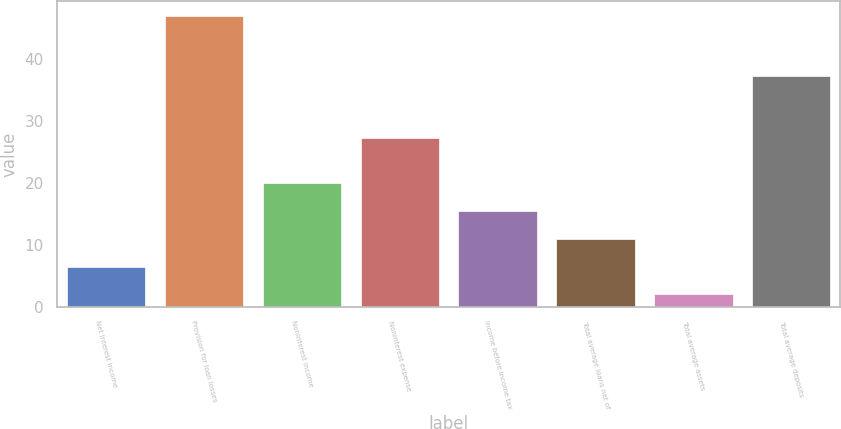Convert chart to OTSL. <chart><loc_0><loc_0><loc_500><loc_500><bar_chart><fcel>Net interest income<fcel>Provision for loan losses<fcel>Noninterest income<fcel>Noninterest expense<fcel>Income before income tax<fcel>Total average loans net of<fcel>Total average assets<fcel>Total average deposits<nl><fcel>6.5<fcel>47<fcel>20<fcel>27.3<fcel>15.5<fcel>11<fcel>2<fcel>37.2<nl></chart> 